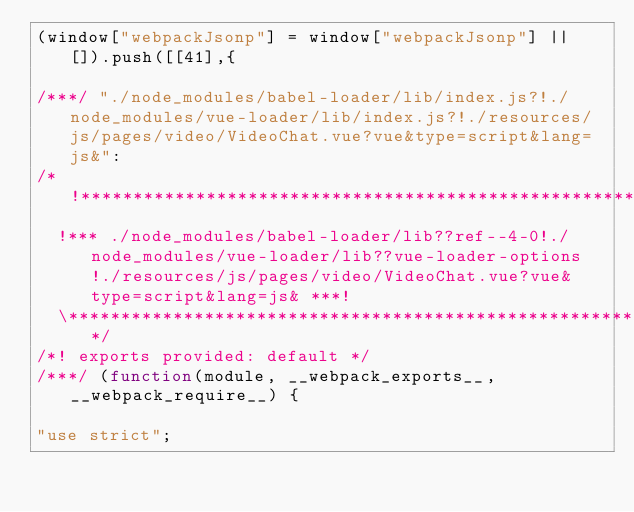<code> <loc_0><loc_0><loc_500><loc_500><_JavaScript_>(window["webpackJsonp"] = window["webpackJsonp"] || []).push([[41],{

/***/ "./node_modules/babel-loader/lib/index.js?!./node_modules/vue-loader/lib/index.js?!./resources/js/pages/video/VideoChat.vue?vue&type=script&lang=js&":
/*!*********************************************************************************************************************************************************************!*\
  !*** ./node_modules/babel-loader/lib??ref--4-0!./node_modules/vue-loader/lib??vue-loader-options!./resources/js/pages/video/VideoChat.vue?vue&type=script&lang=js& ***!
  \*********************************************************************************************************************************************************************/
/*! exports provided: default */
/***/ (function(module, __webpack_exports__, __webpack_require__) {

"use strict";</code> 